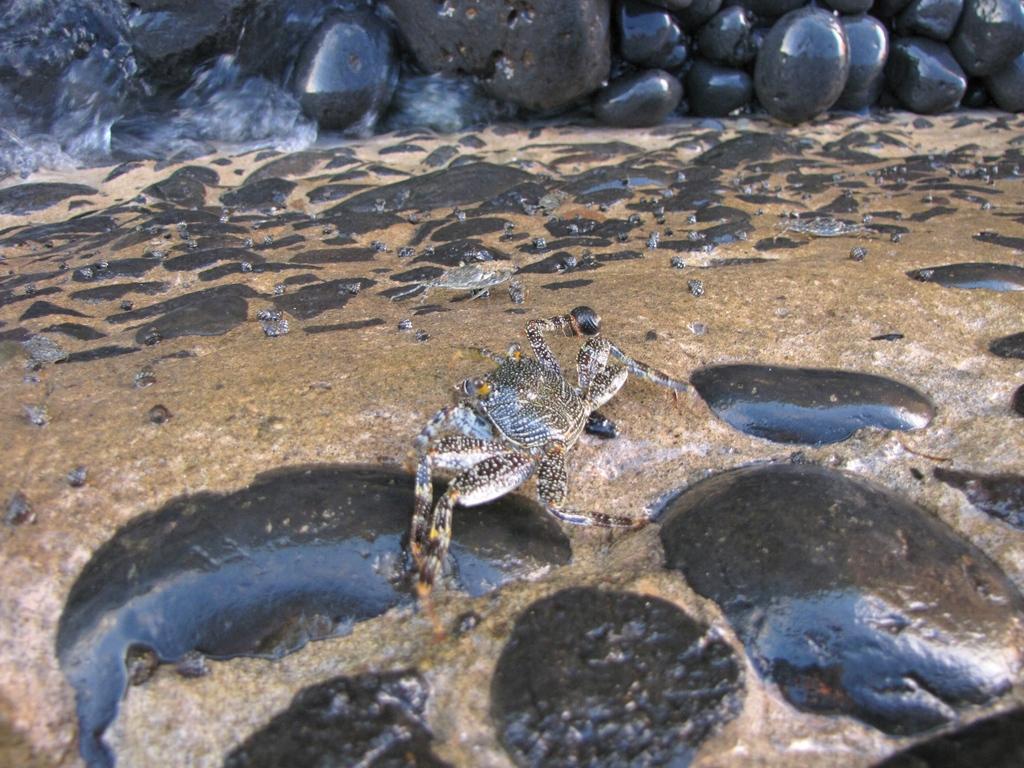Could you give a brief overview of what you see in this image? In the middle of the image, there is a crab walking in the water, which is on the ground, on which there are rocks. In the background, there are rocks arranged. 